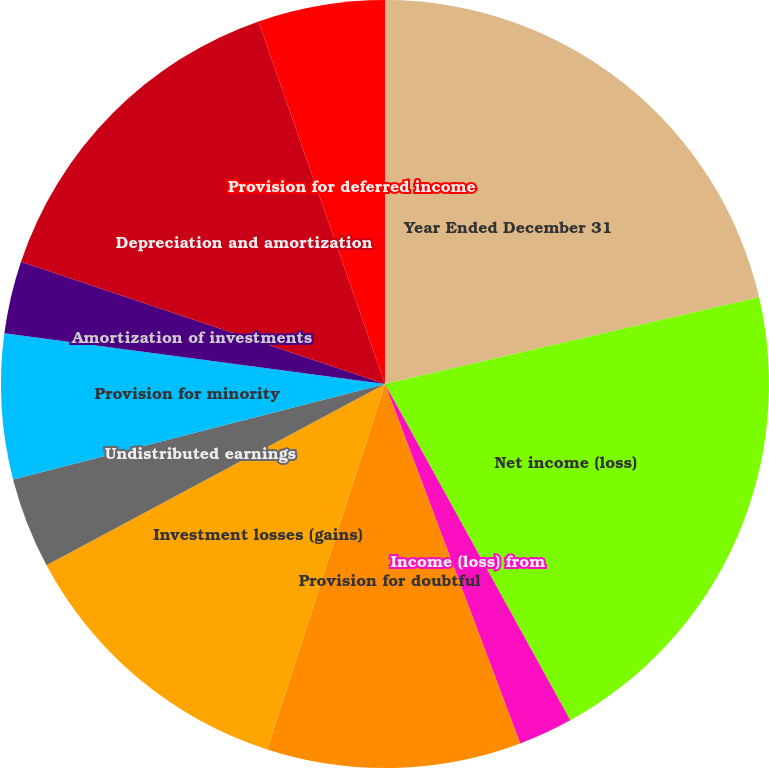Convert chart to OTSL. <chart><loc_0><loc_0><loc_500><loc_500><pie_chart><fcel>Year Ended December 31<fcel>Net income (loss)<fcel>Income (loss) from<fcel>Provision for doubtful<fcel>Investment losses (gains)<fcel>Undistributed earnings<fcel>Provision for minority<fcel>Amortization of investments<fcel>Depreciation and amortization<fcel>Provision for deferred income<nl><fcel>21.37%<fcel>20.61%<fcel>2.29%<fcel>10.69%<fcel>12.21%<fcel>3.82%<fcel>6.11%<fcel>3.05%<fcel>14.5%<fcel>5.34%<nl></chart> 